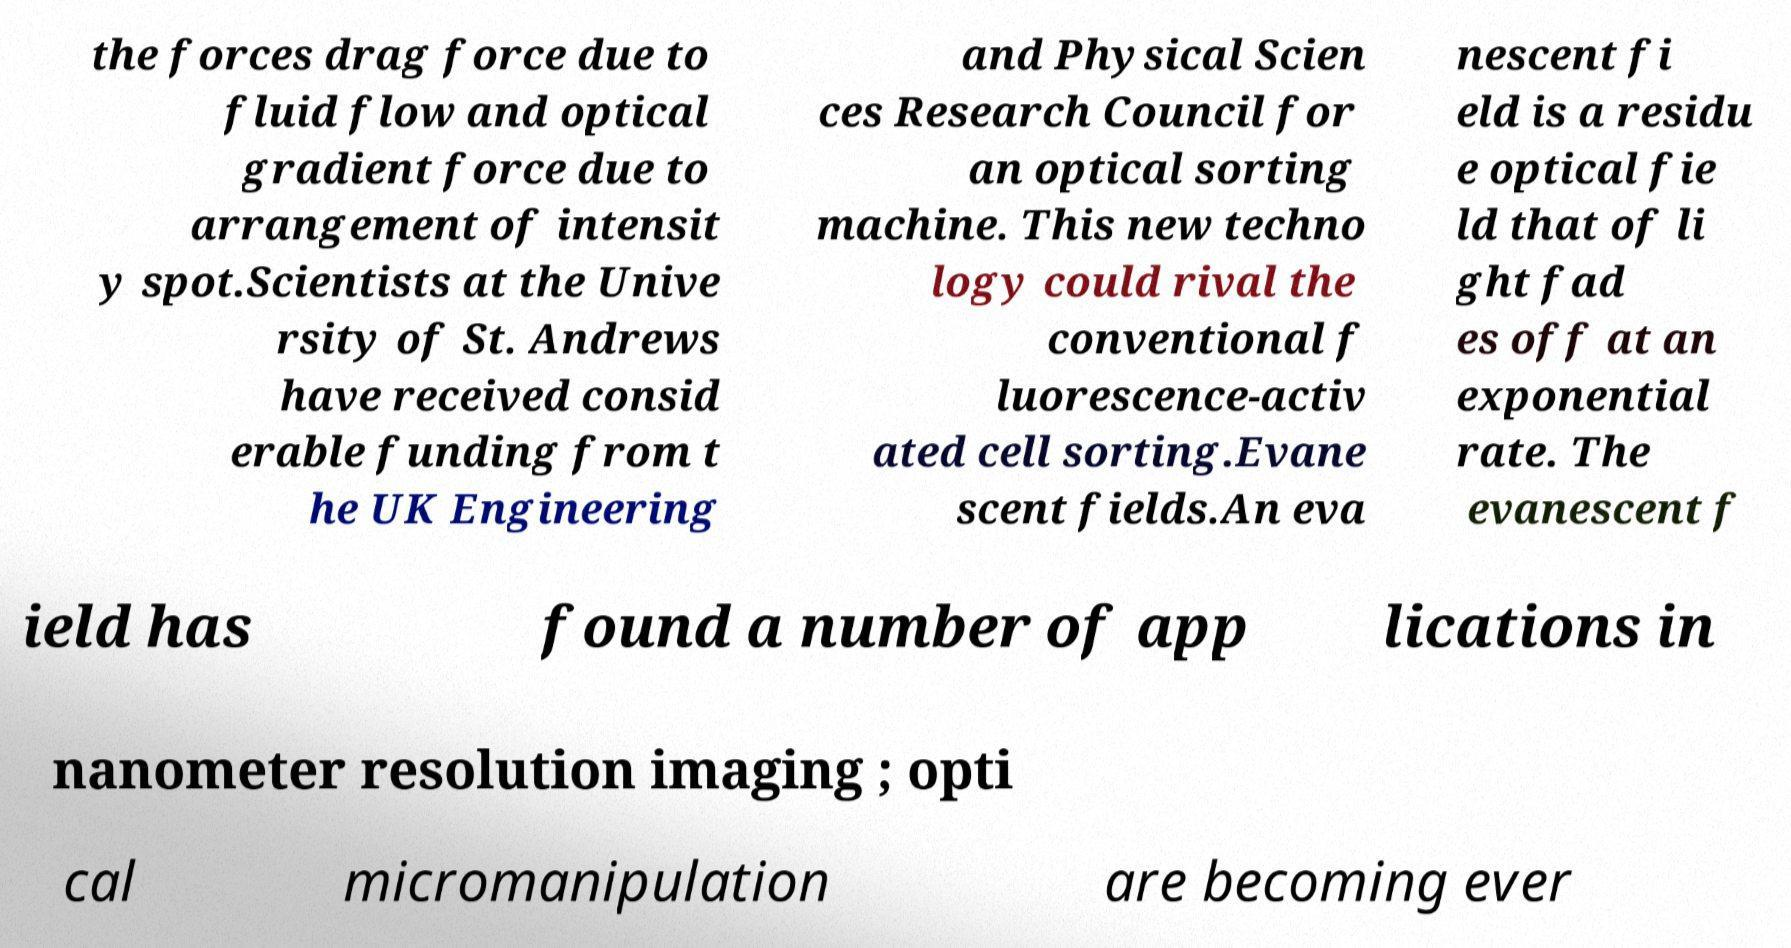Could you assist in decoding the text presented in this image and type it out clearly? the forces drag force due to fluid flow and optical gradient force due to arrangement of intensit y spot.Scientists at the Unive rsity of St. Andrews have received consid erable funding from t he UK Engineering and Physical Scien ces Research Council for an optical sorting machine. This new techno logy could rival the conventional f luorescence-activ ated cell sorting.Evane scent fields.An eva nescent fi eld is a residu e optical fie ld that of li ght fad es off at an exponential rate. The evanescent f ield has found a number of app lications in nanometer resolution imaging ; opti cal micromanipulation are becoming ever 